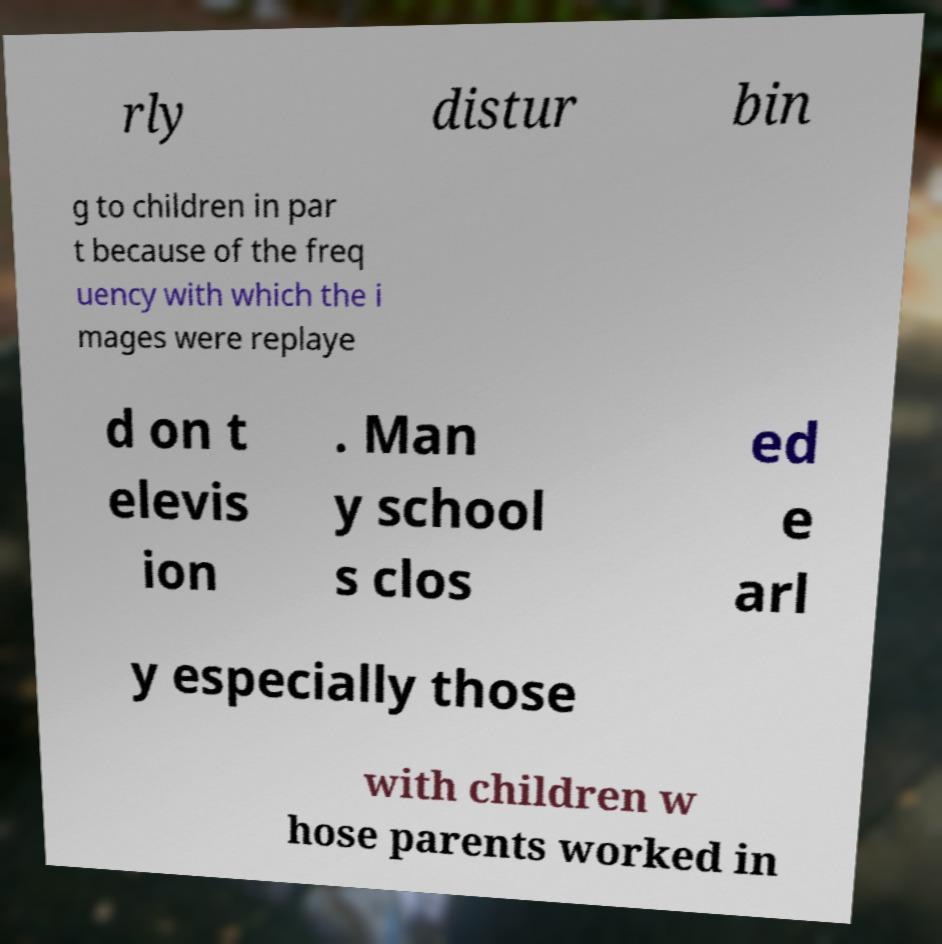Could you extract and type out the text from this image? rly distur bin g to children in par t because of the freq uency with which the i mages were replaye d on t elevis ion . Man y school s clos ed e arl y especially those with children w hose parents worked in 